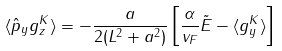<formula> <loc_0><loc_0><loc_500><loc_500>\langle \hat { p } _ { y } g _ { z } ^ { K } \rangle = - \frac { a } { 2 ( L ^ { 2 } + a ^ { 2 } ) } \left [ \frac { \alpha } { v _ { F } } \tilde { E } - \langle g _ { y } ^ { K } \rangle \right ]</formula> 